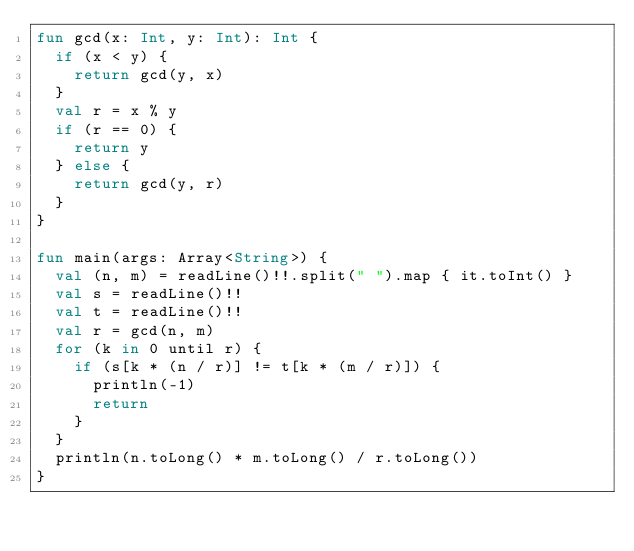Convert code to text. <code><loc_0><loc_0><loc_500><loc_500><_Kotlin_>fun gcd(x: Int, y: Int): Int {
  if (x < y) {
    return gcd(y, x)
  }
  val r = x % y
  if (r == 0) {
    return y
  } else {
    return gcd(y, r)
  }
}

fun main(args: Array<String>) {
  val (n, m) = readLine()!!.split(" ").map { it.toInt() }
  val s = readLine()!!
  val t = readLine()!!
  val r = gcd(n, m)
  for (k in 0 until r) {
    if (s[k * (n / r)] != t[k * (m / r)]) {
      println(-1)
      return
    }
  }
  println(n.toLong() * m.toLong() / r.toLong())
}
</code> 